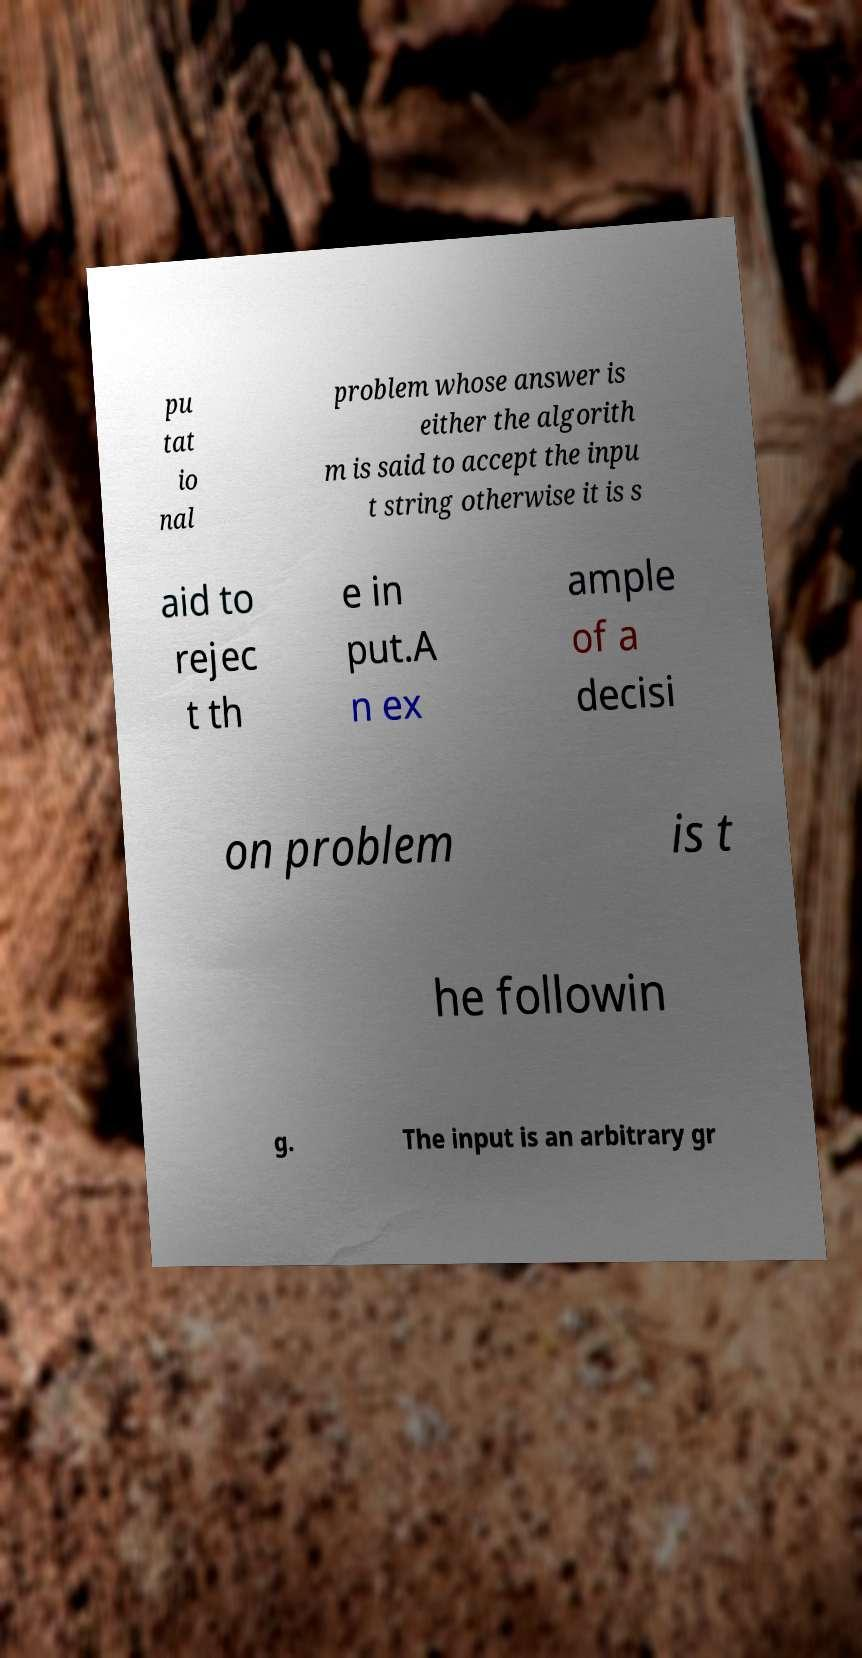Please identify and transcribe the text found in this image. pu tat io nal problem whose answer is either the algorith m is said to accept the inpu t string otherwise it is s aid to rejec t th e in put.A n ex ample of a decisi on problem is t he followin g. The input is an arbitrary gr 